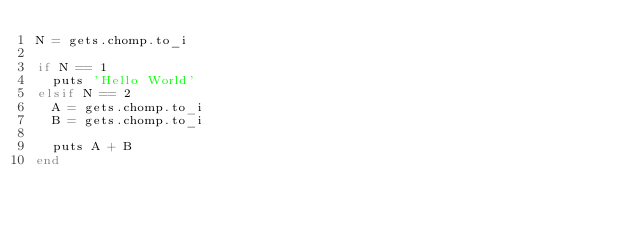<code> <loc_0><loc_0><loc_500><loc_500><_Ruby_>N = gets.chomp.to_i

if N == 1
  puts 'Hello World'
elsif N == 2
  A = gets.chomp.to_i
  B = gets.chomp.to_i

  puts A + B
end



</code> 